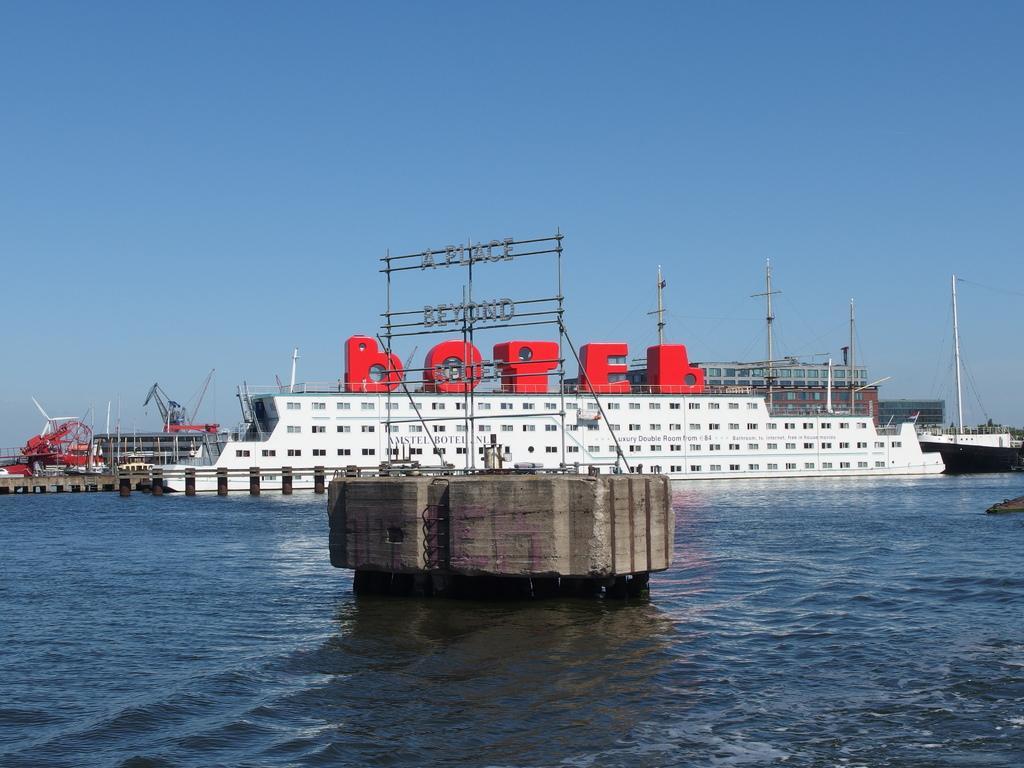In one or two sentences, can you explain what this image depicts? In this image I can see the water, a brown colored object on the surface of the water and a ship which is white and red in color on the surface of the water. In the background I can see few buildings, few cranes, a windmill and the sky. 